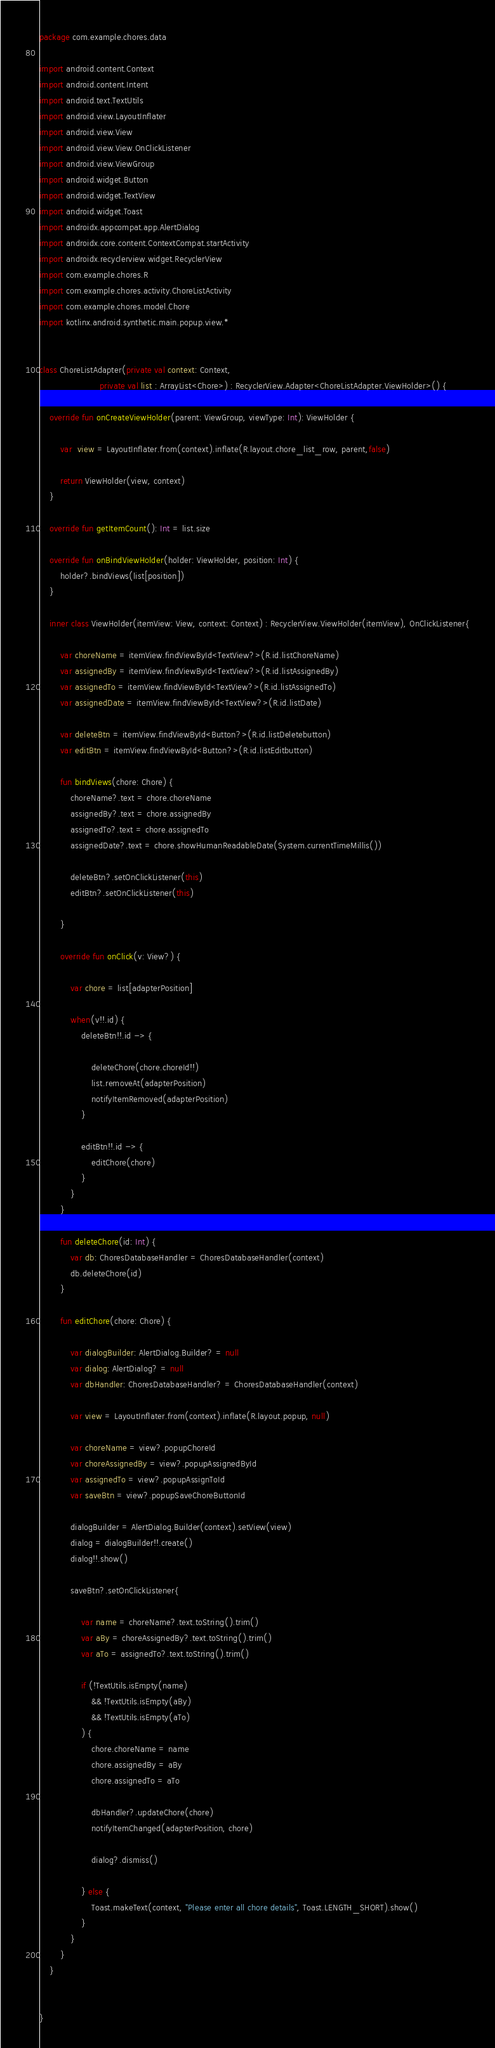<code> <loc_0><loc_0><loc_500><loc_500><_Kotlin_>package com.example.chores.data

import android.content.Context
import android.content.Intent
import android.text.TextUtils
import android.view.LayoutInflater
import android.view.View
import android.view.View.OnClickListener
import android.view.ViewGroup
import android.widget.Button
import android.widget.TextView
import android.widget.Toast
import androidx.appcompat.app.AlertDialog
import androidx.core.content.ContextCompat.startActivity
import androidx.recyclerview.widget.RecyclerView
import com.example.chores.R
import com.example.chores.activity.ChoreListActivity
import com.example.chores.model.Chore
import kotlinx.android.synthetic.main.popup.view.*


class ChoreListAdapter(private val context: Context,
                       private val list : ArrayList<Chore>) : RecyclerView.Adapter<ChoreListAdapter.ViewHolder>() {

    override fun onCreateViewHolder(parent: ViewGroup, viewType: Int): ViewHolder {

        var  view = LayoutInflater.from(context).inflate(R.layout.chore_list_row, parent,false)

        return ViewHolder(view, context)
    }

    override fun getItemCount(): Int = list.size

    override fun onBindViewHolder(holder: ViewHolder, position: Int) {
        holder?.bindViews(list[position])
    }

    inner class ViewHolder(itemView: View, context: Context) : RecyclerView.ViewHolder(itemView), OnClickListener{

        var choreName = itemView.findViewById<TextView?>(R.id.listChoreName)
        var assignedBy = itemView.findViewById<TextView?>(R.id.listAssignedBy)
        var assignedTo = itemView.findViewById<TextView?>(R.id.listAssignedTo)
        var assignedDate = itemView.findViewById<TextView?>(R.id.listDate)

        var deleteBtn = itemView.findViewById<Button?>(R.id.listDeletebutton)
        var editBtn = itemView.findViewById<Button?>(R.id.listEditbutton)

        fun bindViews(chore: Chore) {
            choreName?.text = chore.choreName
            assignedBy?.text = chore.assignedBy
            assignedTo?.text = chore.assignedTo
            assignedDate?.text = chore.showHumanReadableDate(System.currentTimeMillis())

            deleteBtn?.setOnClickListener(this)
            editBtn?.setOnClickListener(this)

        }

        override fun onClick(v: View?) {

            var chore = list[adapterPosition]

            when(v!!.id) {
                deleteBtn!!.id -> {

                    deleteChore(chore.choreId!!)
                    list.removeAt(adapterPosition)
                    notifyItemRemoved(adapterPosition)
                }

                editBtn!!.id -> {
                    editChore(chore)
                }
            }
        }

        fun deleteChore(id: Int) {
            var db: ChoresDatabaseHandler = ChoresDatabaseHandler(context)
            db.deleteChore(id)
        }

        fun editChore(chore: Chore) {

            var dialogBuilder: AlertDialog.Builder? = null
            var dialog: AlertDialog? = null
            var dbHandler: ChoresDatabaseHandler? = ChoresDatabaseHandler(context)

            var view = LayoutInflater.from(context).inflate(R.layout.popup, null)

            var choreName = view?.popupChoreId
            var choreAssignedBy = view?.popupAssignedById
            var assignedTo = view?.popupAssignToId
            var saveBtn = view?.popupSaveChoreButtonId

            dialogBuilder = AlertDialog.Builder(context).setView(view)
            dialog = dialogBuilder!!.create()
            dialog!!.show()

            saveBtn?.setOnClickListener{

                var name = choreName?.text.toString().trim()
                var aBy = choreAssignedBy?.text.toString().trim()
                var aTo = assignedTo?.text.toString().trim()

                if (!TextUtils.isEmpty(name)
                    && !TextUtils.isEmpty(aBy)
                    && !TextUtils.isEmpty(aTo)
                ) {
                    chore.choreName = name
                    chore.assignedBy = aBy
                    chore.assignedTo = aTo

                    dbHandler?.updateChore(chore)
                    notifyItemChanged(adapterPosition, chore)

                    dialog?.dismiss()

                } else {
                    Toast.makeText(context, "Please enter all chore details", Toast.LENGTH_SHORT).show()
                }
            }
        }
    }


}</code> 